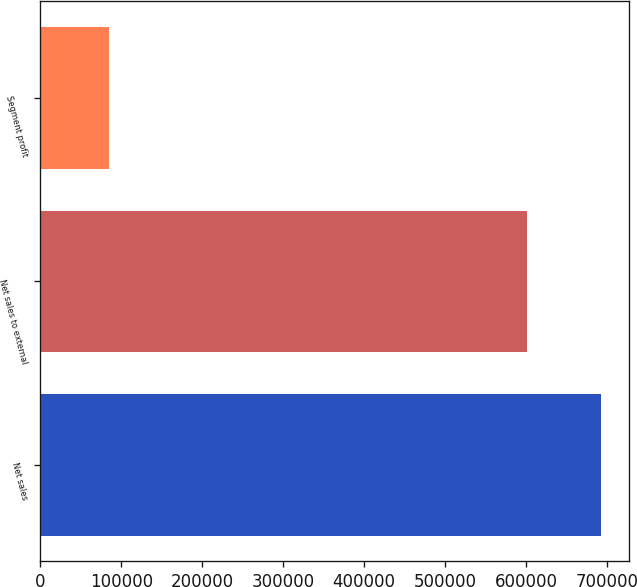Convert chart to OTSL. <chart><loc_0><loc_0><loc_500><loc_500><bar_chart><fcel>Net sales<fcel>Net sales to external<fcel>Segment profit<nl><fcel>692255<fcel>600933<fcel>85120<nl></chart> 